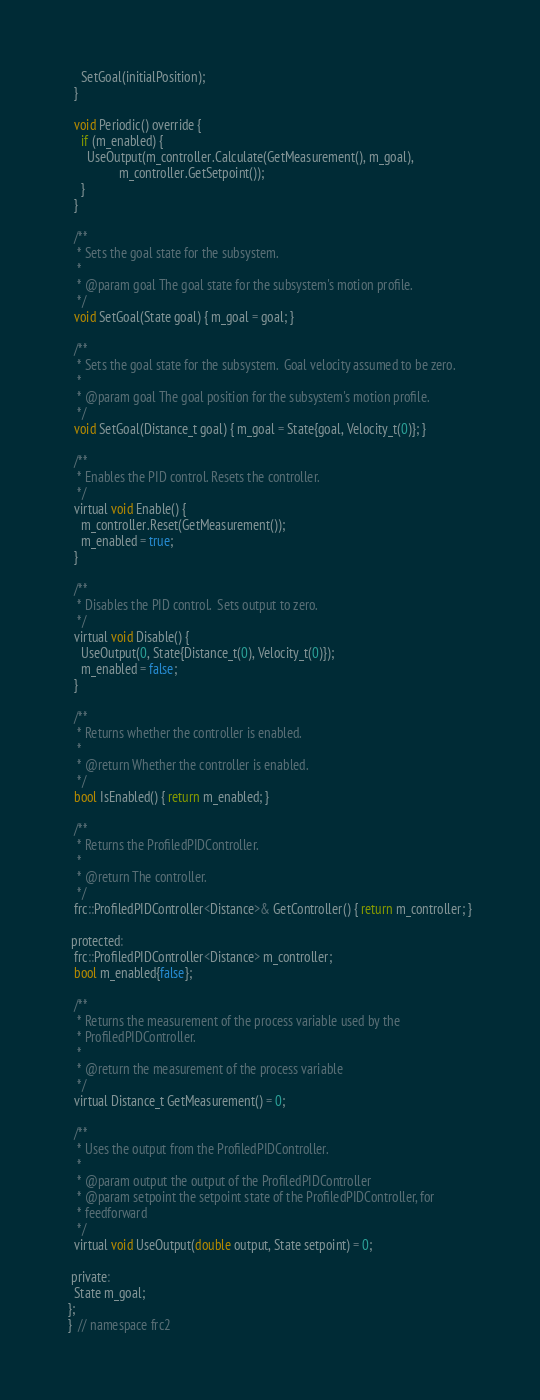Convert code to text. <code><loc_0><loc_0><loc_500><loc_500><_C_>    SetGoal(initialPosition);
  }

  void Periodic() override {
    if (m_enabled) {
      UseOutput(m_controller.Calculate(GetMeasurement(), m_goal),
                m_controller.GetSetpoint());
    }
  }

  /**
   * Sets the goal state for the subsystem.
   *
   * @param goal The goal state for the subsystem's motion profile.
   */
  void SetGoal(State goal) { m_goal = goal; }

  /**
   * Sets the goal state for the subsystem.  Goal velocity assumed to be zero.
   *
   * @param goal The goal position for the subsystem's motion profile.
   */
  void SetGoal(Distance_t goal) { m_goal = State{goal, Velocity_t(0)}; }

  /**
   * Enables the PID control. Resets the controller.
   */
  virtual void Enable() {
    m_controller.Reset(GetMeasurement());
    m_enabled = true;
  }

  /**
   * Disables the PID control.  Sets output to zero.
   */
  virtual void Disable() {
    UseOutput(0, State{Distance_t(0), Velocity_t(0)});
    m_enabled = false;
  }

  /**
   * Returns whether the controller is enabled.
   *
   * @return Whether the controller is enabled.
   */
  bool IsEnabled() { return m_enabled; }

  /**
   * Returns the ProfiledPIDController.
   *
   * @return The controller.
   */
  frc::ProfiledPIDController<Distance>& GetController() { return m_controller; }

 protected:
  frc::ProfiledPIDController<Distance> m_controller;
  bool m_enabled{false};

  /**
   * Returns the measurement of the process variable used by the
   * ProfiledPIDController.
   *
   * @return the measurement of the process variable
   */
  virtual Distance_t GetMeasurement() = 0;

  /**
   * Uses the output from the ProfiledPIDController.
   *
   * @param output the output of the ProfiledPIDController
   * @param setpoint the setpoint state of the ProfiledPIDController, for
   * feedforward
   */
  virtual void UseOutput(double output, State setpoint) = 0;

 private:
  State m_goal;
};
}  // namespace frc2
</code> 